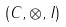Convert formula to latex. <formula><loc_0><loc_0><loc_500><loc_500>( C , \otimes , I )</formula> 